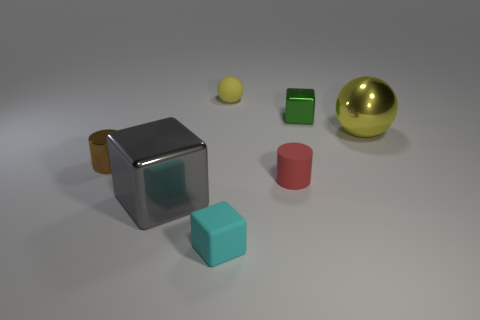Add 1 yellow metallic things. How many objects exist? 8 Subtract all cylinders. How many objects are left? 5 Subtract all cyan objects. Subtract all small objects. How many objects are left? 1 Add 2 green metallic things. How many green metallic things are left? 3 Add 4 large gray cylinders. How many large gray cylinders exist? 4 Subtract 0 cyan spheres. How many objects are left? 7 